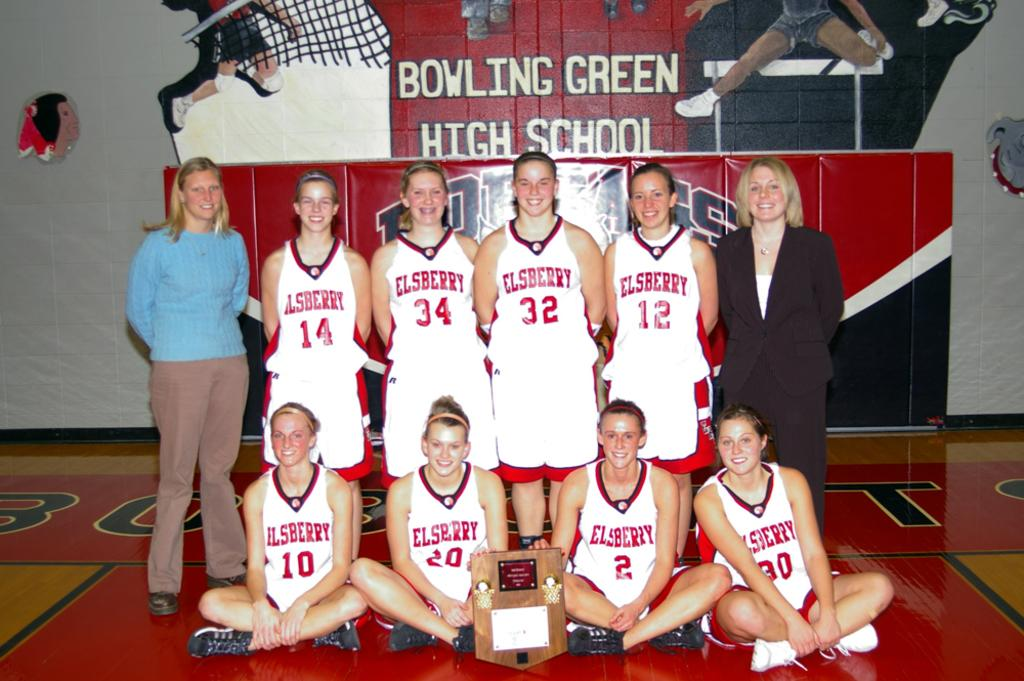<image>
Present a compact description of the photo's key features. some people with the name Elsberry on their jerseys 